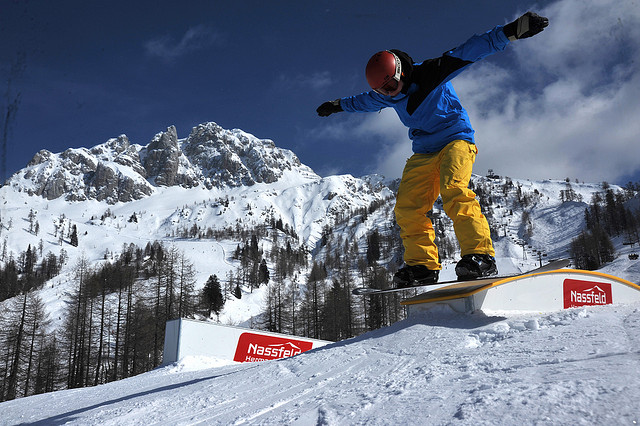What kind of trick is the snowboarder performing? The snowboarder appears to be performing a rail slide, which involves gliding along a rail using the base of the snowboard. This trick requires balance and precision, showcasing the rider's skill. 